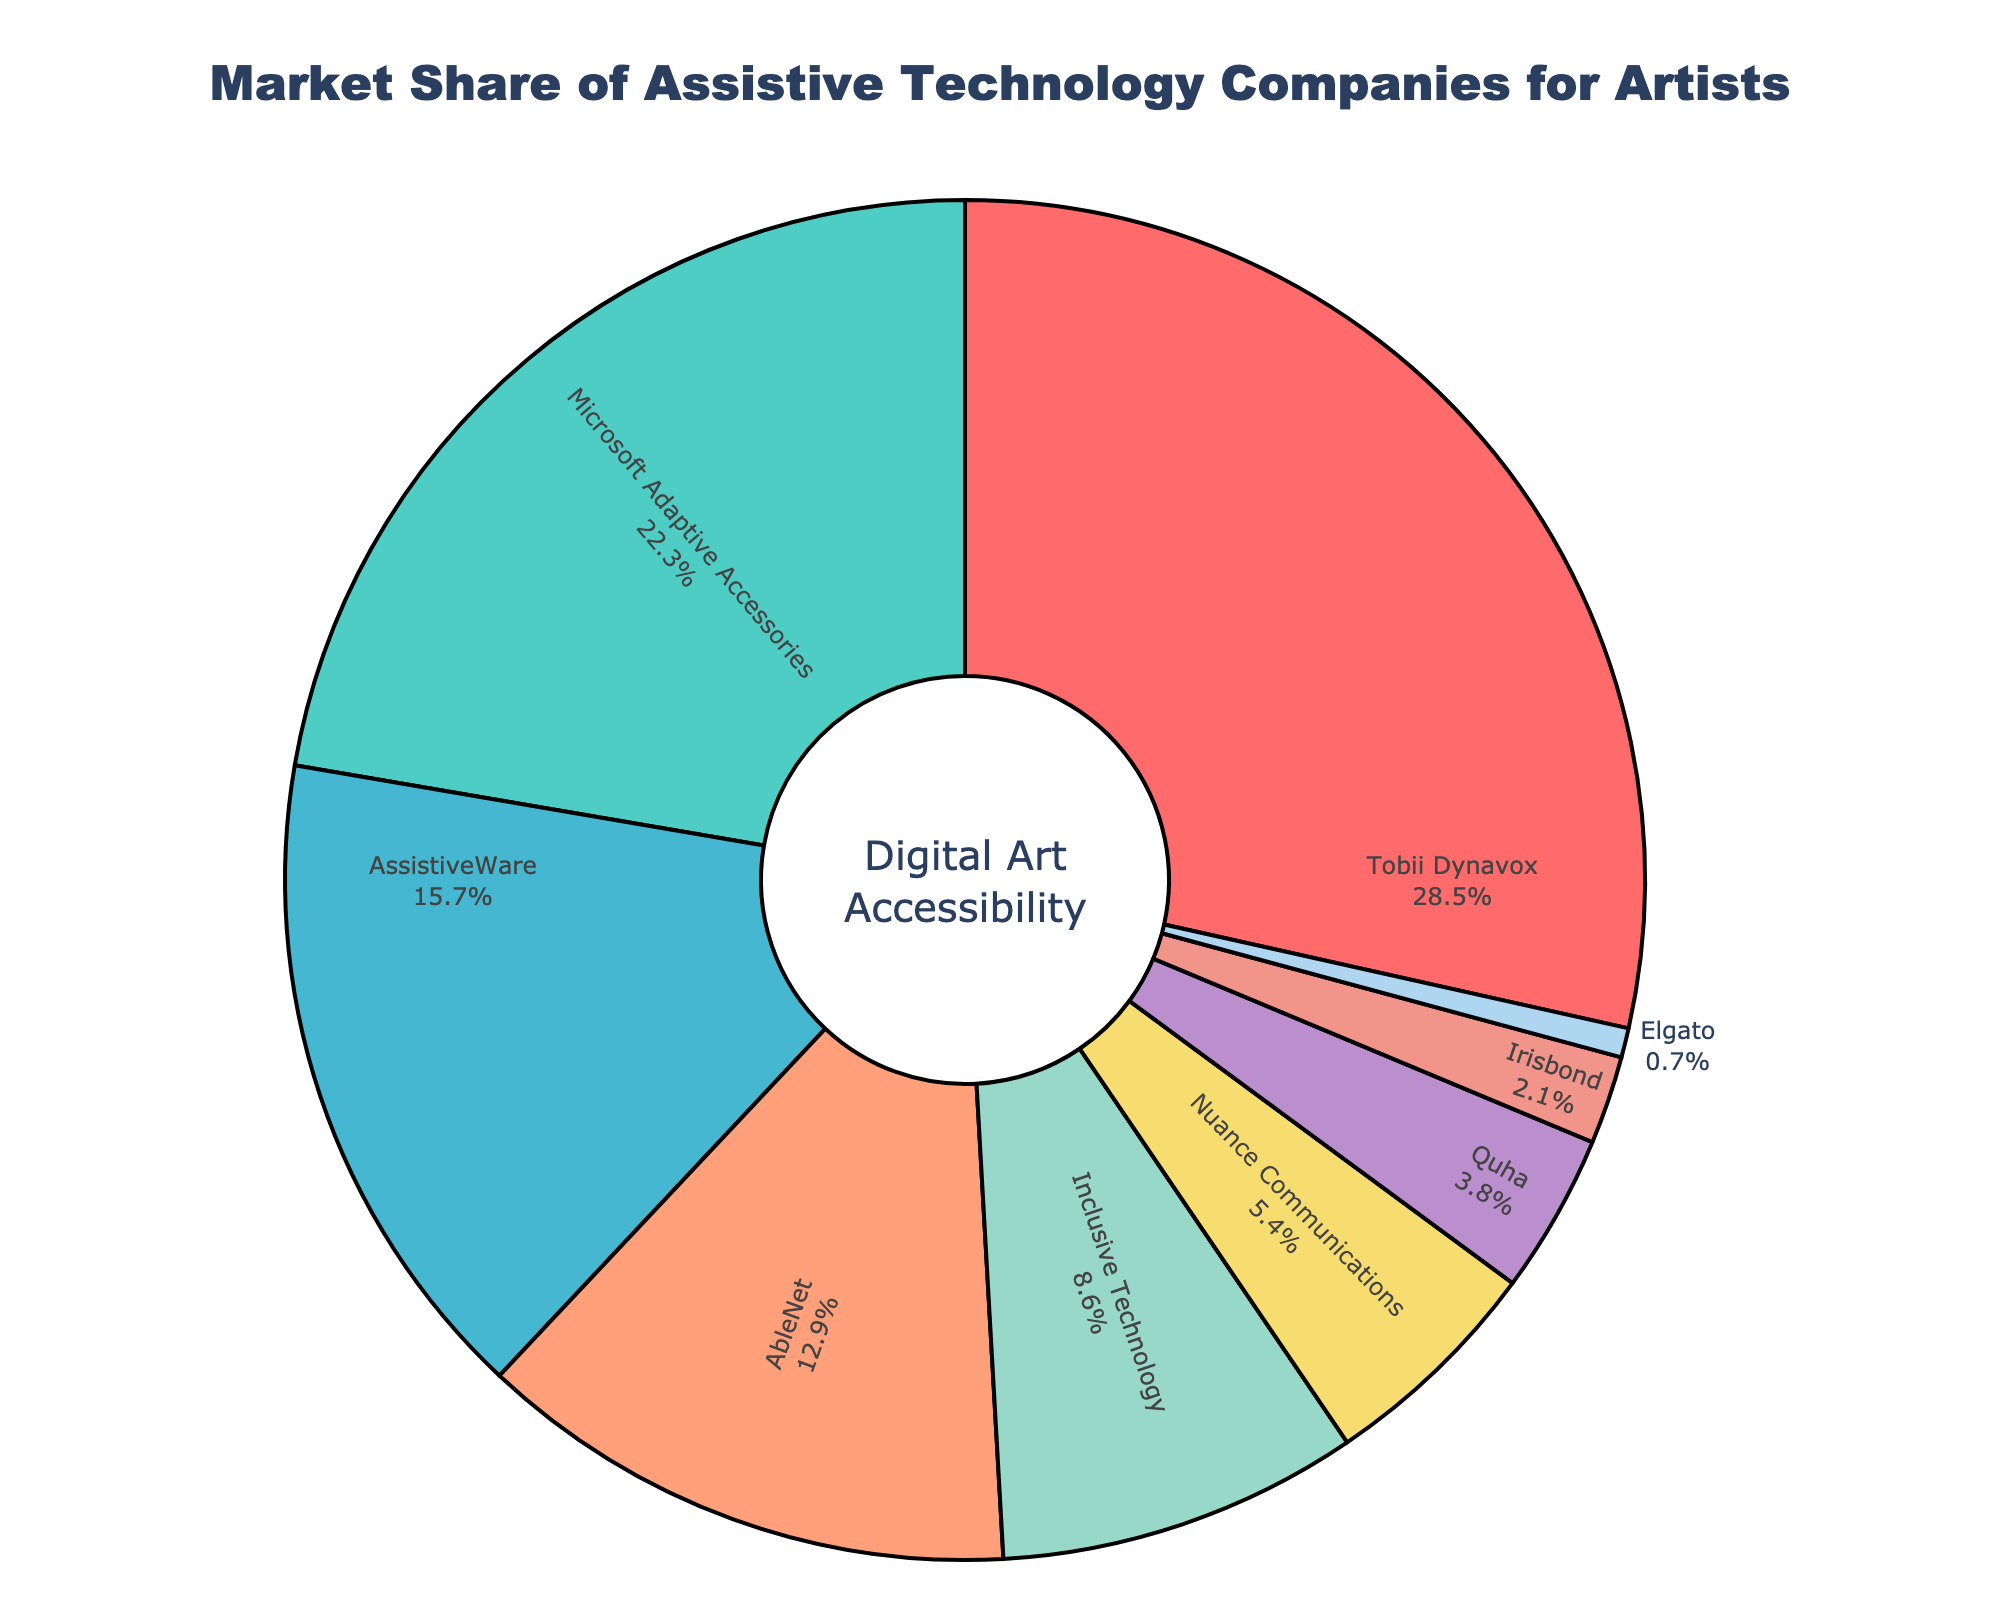What's the highest market share held by a single company? Locate the largest segment in the pie chart. Tobii Dynavox has the largest slice, occupying 28.5% of the market share.
Answer: 28.5% Which company holds a larger market share: Microsoft Adaptive Accessories or AssistiveWare? Compare the slices representing Microsoft Adaptive Accessories and AssistiveWare. Microsoft Adaptive Accessories has 22.3%, which is larger than AssistiveWare's 15.7%.
Answer: Microsoft Adaptive Accessories What is the combined market share of AbleNet and Inclusive Technology? Identify the market shares of AbleNet (12.9%) and Inclusive Technology (8.6%), then add these values: 12.9% + 8.6% = 21.5%.
Answer: 21.5% Does Nuance Communications hold more or less than 5% market share? Locate Nuance Communications on the chart, which has a market share of 5.4%. This is more than 5%.
Answer: More How many companies have a market share below 10%? Count the segments with market shares less than 10%: Inclusive Technology (8.6%), Nuance Communications (5.4%), Quha (3.8%), Irisbond (2.1%), and Elgato (0.7%). There are 5 companies.
Answer: 5 What is the market share of the company represented by the green color? Identify the segment with the green color, which corresponds to Microsoft Adaptive Accessories with a market share of 22.3%.
Answer: 22.3% Which company has the smallest market share and what is it? Identify the smallest segment in the chart. Elgato has the smallest share at 0.7%.
Answer: Elgato, 0.7% What is the difference in market share between Tobii Dynavox and Nuance Communications? Subtract Nuance Communications' market share (5.4%) from Tobii Dynavox's market share (28.5%): 28.5% - 5.4% = 23.1%.
Answer: 23.1% Which company has about half the market share of AbleNet? AbleNet has a 12.9% market share, and half of that is approximately 6.45%. Compare with other segments to find the closest match. Nuance Communications has 5.4%, which is closest to half of 12.9%.
Answer: Nuance Communications What is the total market share of all companies with a market share above 20%? Identify companies with market shares above 20%: Tobii Dynavox (28.5%) and Microsoft Adaptive Accessories (22.3%). Add these values: 28.5% + 22.3% = 50.8%.
Answer: 50.8% 